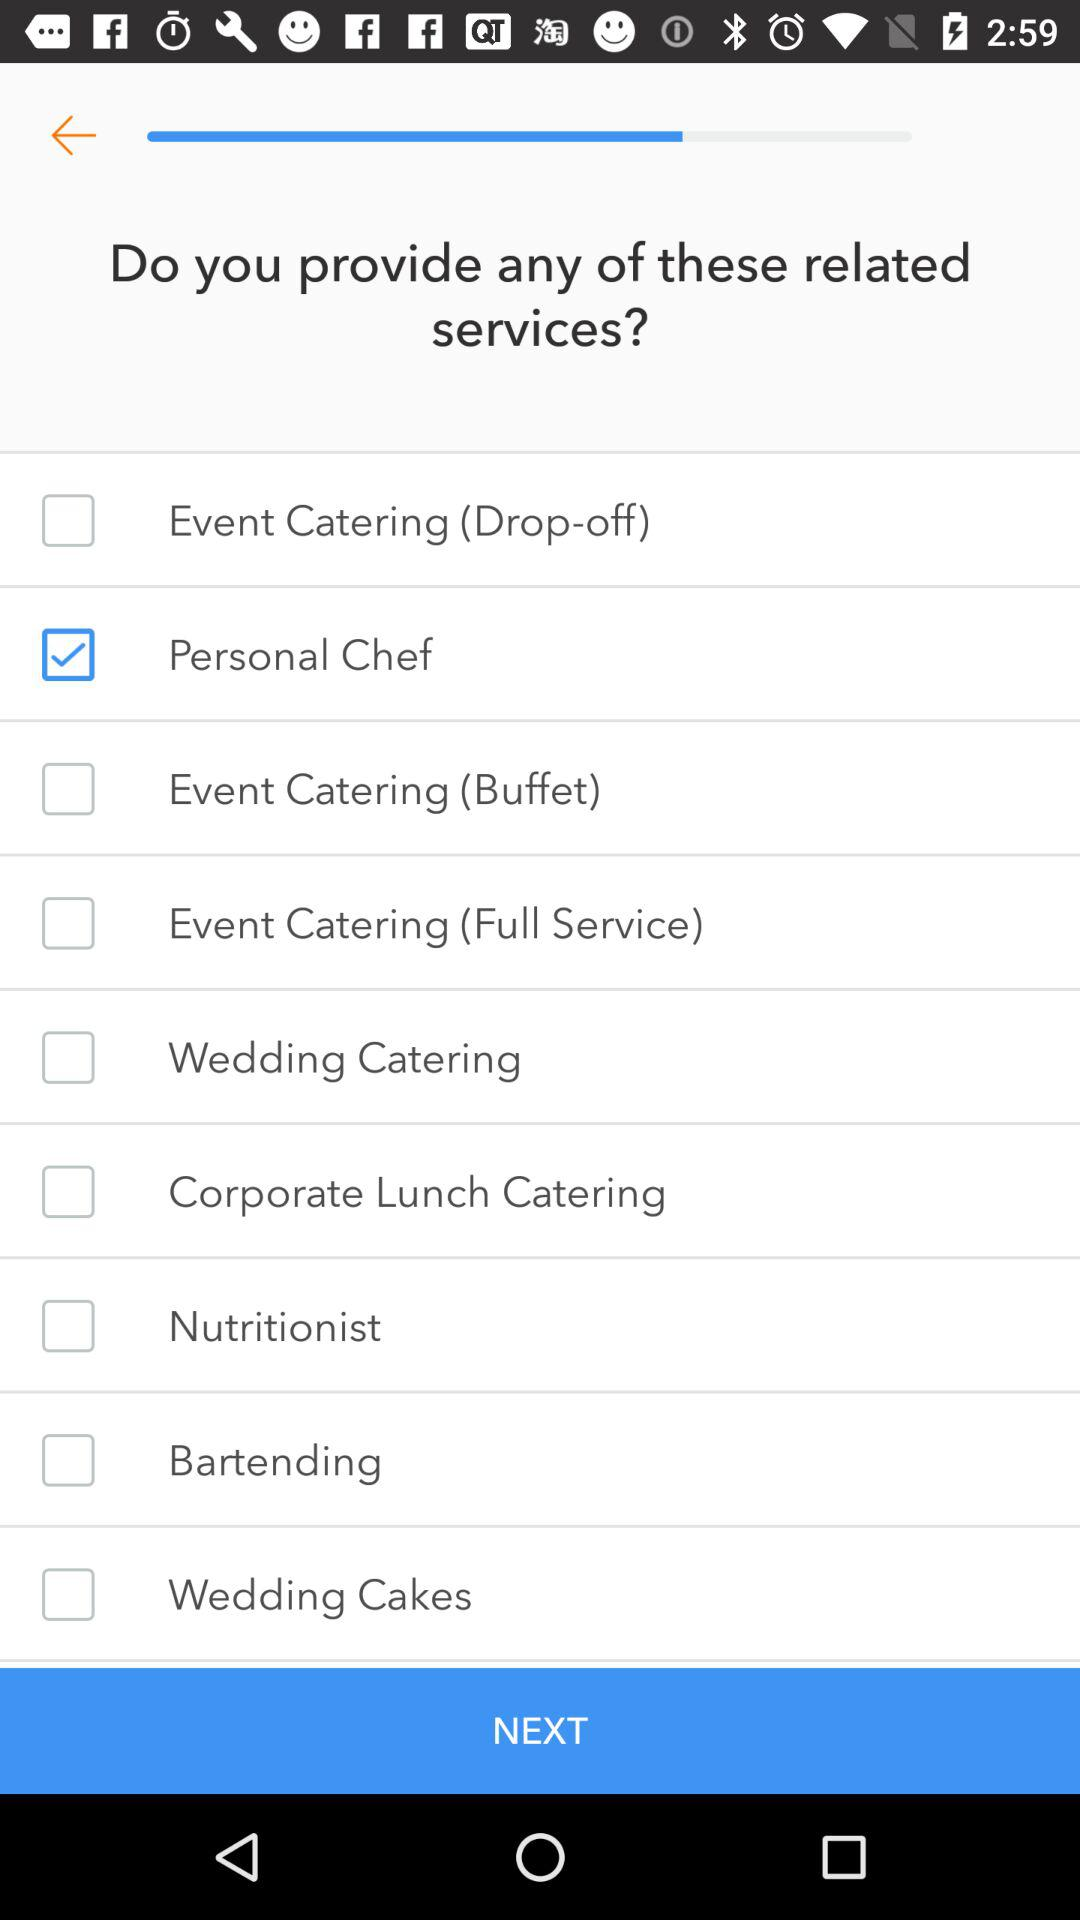Which option is selected? The selected option is "Personal Chef". 